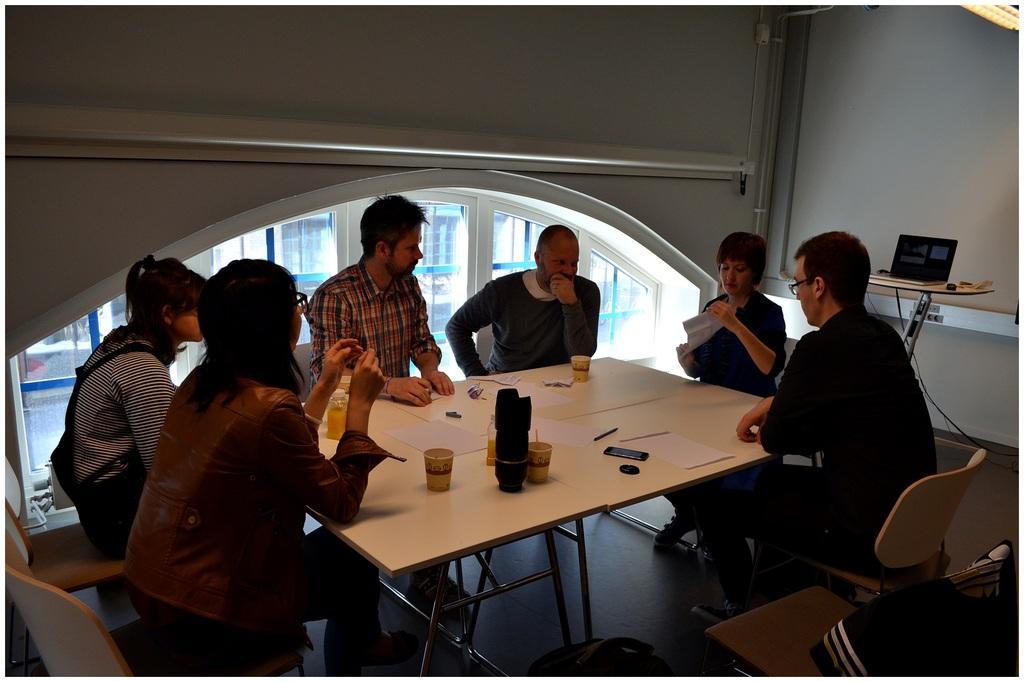Can you describe this image briefly? In the image we can see there are people who are sitting on chair and in front of them there is a table on which there is glass, mobile phone, paper and pen. 